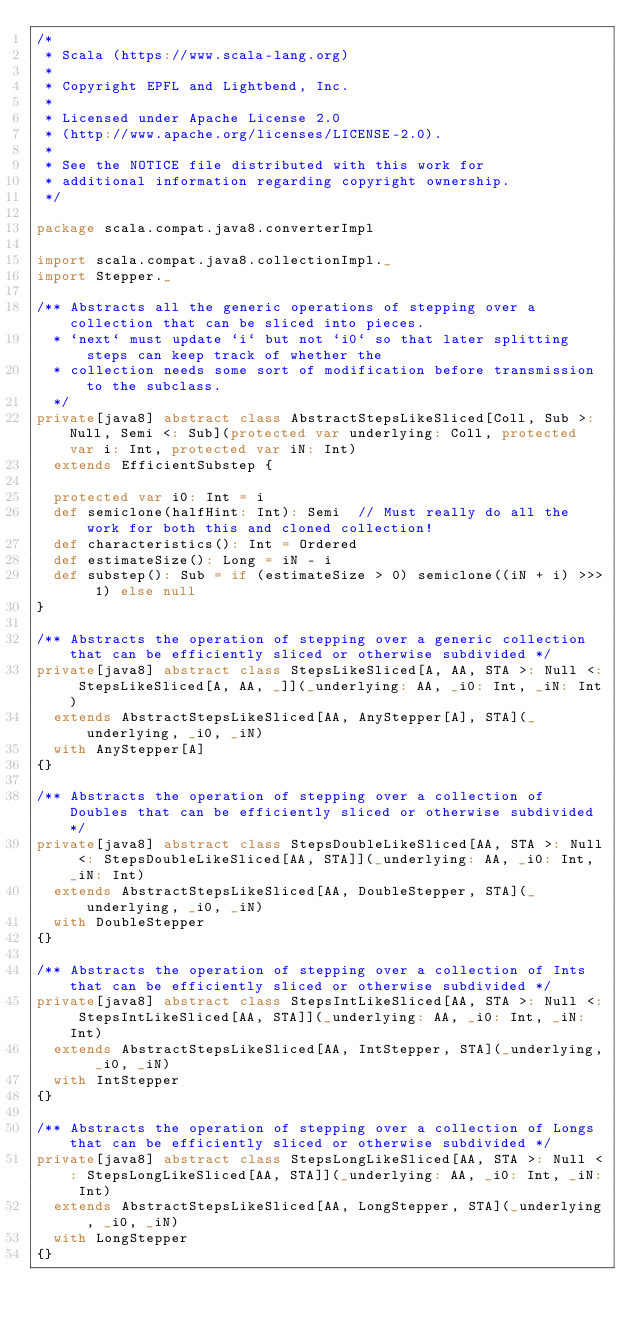Convert code to text. <code><loc_0><loc_0><loc_500><loc_500><_Scala_>/*
 * Scala (https://www.scala-lang.org)
 *
 * Copyright EPFL and Lightbend, Inc.
 *
 * Licensed under Apache License 2.0
 * (http://www.apache.org/licenses/LICENSE-2.0).
 *
 * See the NOTICE file distributed with this work for
 * additional information regarding copyright ownership.
 */

package scala.compat.java8.converterImpl

import scala.compat.java8.collectionImpl._
import Stepper._

/** Abstracts all the generic operations of stepping over a collection that can be sliced into pieces.
  * `next` must update `i` but not `i0` so that later splitting steps can keep track of whether the
  * collection needs some sort of modification before transmission to the subclass.
  */
private[java8] abstract class AbstractStepsLikeSliced[Coll, Sub >: Null, Semi <: Sub](protected var underlying: Coll, protected var i: Int, protected var iN: Int)
  extends EfficientSubstep {

  protected var i0: Int = i
  def semiclone(halfHint: Int): Semi  // Must really do all the work for both this and cloned collection!
  def characteristics(): Int = Ordered
  def estimateSize(): Long = iN - i
  def substep(): Sub = if (estimateSize > 0) semiclone((iN + i) >>> 1) else null
}

/** Abstracts the operation of stepping over a generic collection that can be efficiently sliced or otherwise subdivided */
private[java8] abstract class StepsLikeSliced[A, AA, STA >: Null <: StepsLikeSliced[A, AA, _]](_underlying: AA, _i0: Int, _iN: Int)
  extends AbstractStepsLikeSliced[AA, AnyStepper[A], STA](_underlying, _i0, _iN)
  with AnyStepper[A]
{}

/** Abstracts the operation of stepping over a collection of Doubles that can be efficiently sliced or otherwise subdivided */
private[java8] abstract class StepsDoubleLikeSliced[AA, STA >: Null <: StepsDoubleLikeSliced[AA, STA]](_underlying: AA, _i0: Int, _iN: Int)
  extends AbstractStepsLikeSliced[AA, DoubleStepper, STA](_underlying, _i0, _iN)
  with DoubleStepper
{}

/** Abstracts the operation of stepping over a collection of Ints that can be efficiently sliced or otherwise subdivided */
private[java8] abstract class StepsIntLikeSliced[AA, STA >: Null <: StepsIntLikeSliced[AA, STA]](_underlying: AA, _i0: Int, _iN: Int)
  extends AbstractStepsLikeSliced[AA, IntStepper, STA](_underlying, _i0, _iN)
  with IntStepper
{}

/** Abstracts the operation of stepping over a collection of Longs that can be efficiently sliced or otherwise subdivided */
private[java8] abstract class StepsLongLikeSliced[AA, STA >: Null <: StepsLongLikeSliced[AA, STA]](_underlying: AA, _i0: Int, _iN: Int)
  extends AbstractStepsLikeSliced[AA, LongStepper, STA](_underlying, _i0, _iN)
  with LongStepper
{}
</code> 